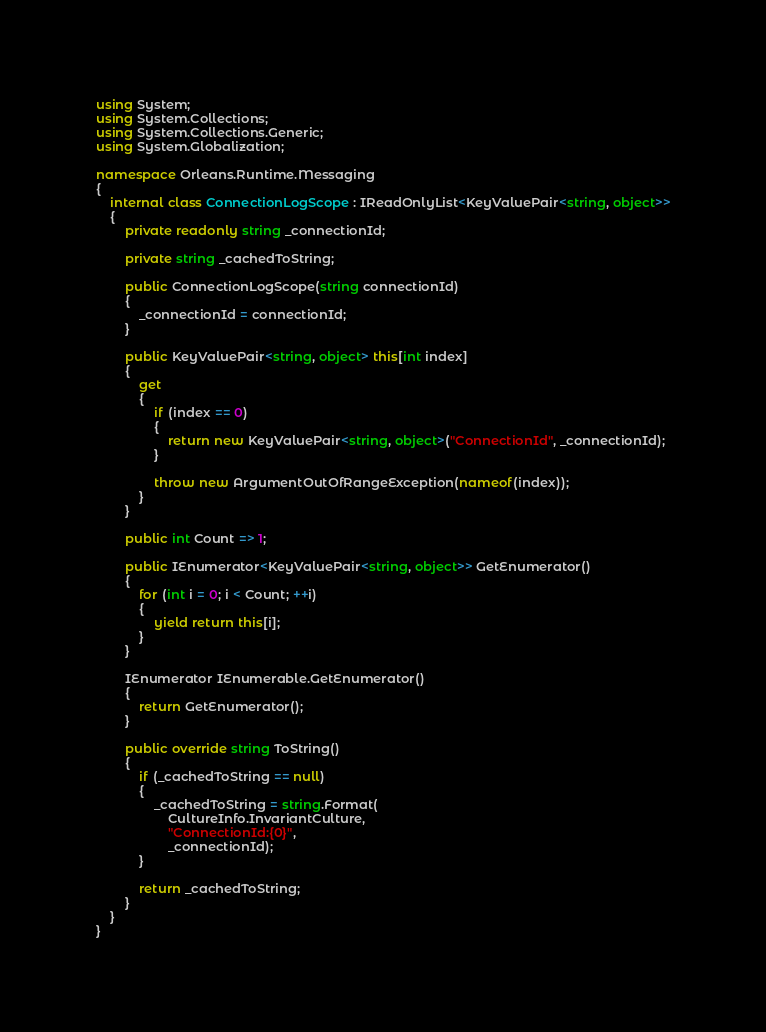Convert code to text. <code><loc_0><loc_0><loc_500><loc_500><_C#_>using System;
using System.Collections;
using System.Collections.Generic;
using System.Globalization;

namespace Orleans.Runtime.Messaging
{
    internal class ConnectionLogScope : IReadOnlyList<KeyValuePair<string, object>>
    {
        private readonly string _connectionId;

        private string _cachedToString;

        public ConnectionLogScope(string connectionId)
        {
            _connectionId = connectionId;
        }

        public KeyValuePair<string, object> this[int index]
        {
            get
            {
                if (index == 0)
                {
                    return new KeyValuePair<string, object>("ConnectionId", _connectionId);
                }

                throw new ArgumentOutOfRangeException(nameof(index));
            }
        }

        public int Count => 1;

        public IEnumerator<KeyValuePair<string, object>> GetEnumerator()
        {
            for (int i = 0; i < Count; ++i)
            {
                yield return this[i];
            }
        }

        IEnumerator IEnumerable.GetEnumerator()
        {
            return GetEnumerator();
        }

        public override string ToString()
        {
            if (_cachedToString == null)
            {
                _cachedToString = string.Format(
                    CultureInfo.InvariantCulture,
                    "ConnectionId:{0}",
                    _connectionId);
            }

            return _cachedToString;
        }
    }
}
</code> 